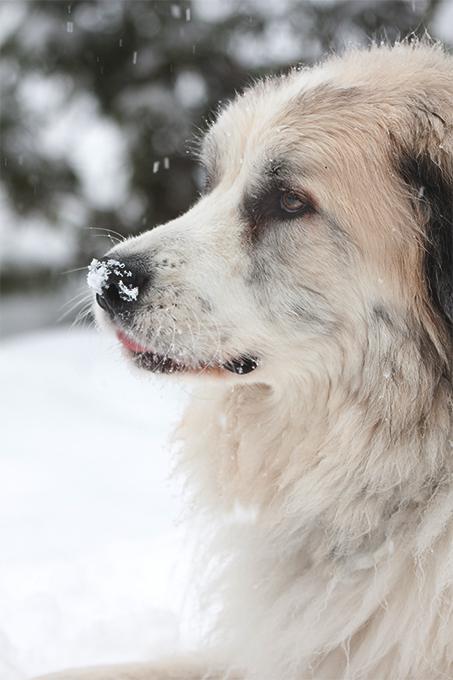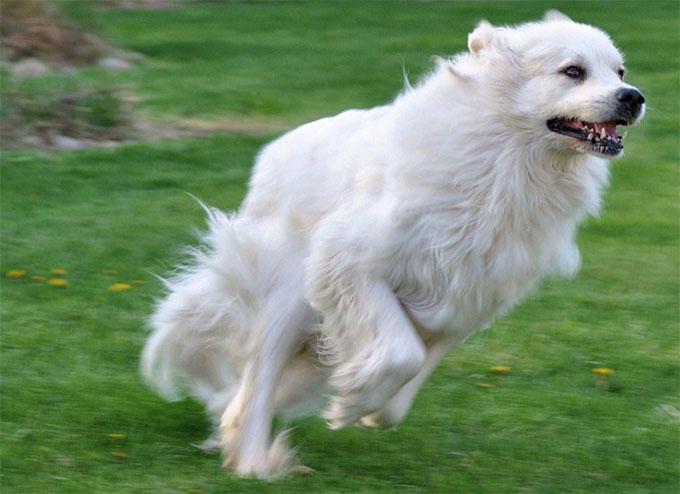The first image is the image on the left, the second image is the image on the right. Assess this claim about the two images: "All images show one adult dog standing still outdoors.". Correct or not? Answer yes or no. No. The first image is the image on the left, the second image is the image on the right. For the images displayed, is the sentence "All images show one dog that is standing." factually correct? Answer yes or no. No. 